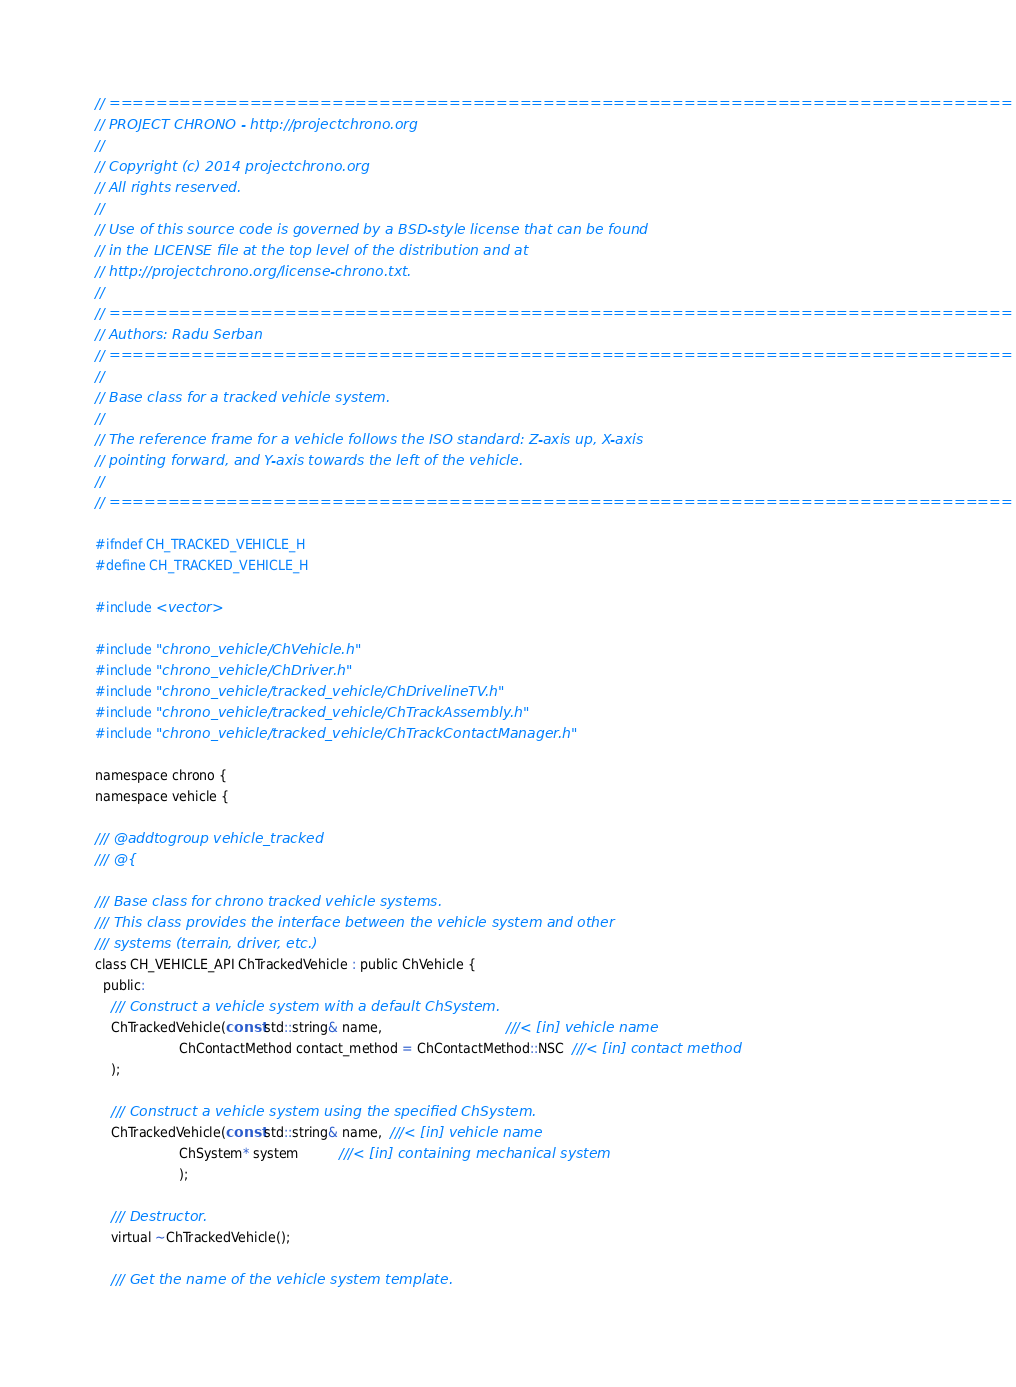<code> <loc_0><loc_0><loc_500><loc_500><_C_>// =============================================================================
// PROJECT CHRONO - http://projectchrono.org
//
// Copyright (c) 2014 projectchrono.org
// All rights reserved.
//
// Use of this source code is governed by a BSD-style license that can be found
// in the LICENSE file at the top level of the distribution and at
// http://projectchrono.org/license-chrono.txt.
//
// =============================================================================
// Authors: Radu Serban
// =============================================================================
//
// Base class for a tracked vehicle system.
//
// The reference frame for a vehicle follows the ISO standard: Z-axis up, X-axis
// pointing forward, and Y-axis towards the left of the vehicle.
//
// =============================================================================

#ifndef CH_TRACKED_VEHICLE_H
#define CH_TRACKED_VEHICLE_H

#include <vector>

#include "chrono_vehicle/ChVehicle.h"
#include "chrono_vehicle/ChDriver.h"
#include "chrono_vehicle/tracked_vehicle/ChDrivelineTV.h"
#include "chrono_vehicle/tracked_vehicle/ChTrackAssembly.h"
#include "chrono_vehicle/tracked_vehicle/ChTrackContactManager.h"

namespace chrono {
namespace vehicle {

/// @addtogroup vehicle_tracked
/// @{

/// Base class for chrono tracked vehicle systems.
/// This class provides the interface between the vehicle system and other
/// systems (terrain, driver, etc.)
class CH_VEHICLE_API ChTrackedVehicle : public ChVehicle {
  public:
    /// Construct a vehicle system with a default ChSystem.
    ChTrackedVehicle(const std::string& name,                               ///< [in] vehicle name
                     ChContactMethod contact_method = ChContactMethod::NSC  ///< [in] contact method
    );

    /// Construct a vehicle system using the specified ChSystem.
    ChTrackedVehicle(const std::string& name,  ///< [in] vehicle name
                     ChSystem* system          ///< [in] containing mechanical system
                     );

    /// Destructor.
    virtual ~ChTrackedVehicle();

    /// Get the name of the vehicle system template.</code> 